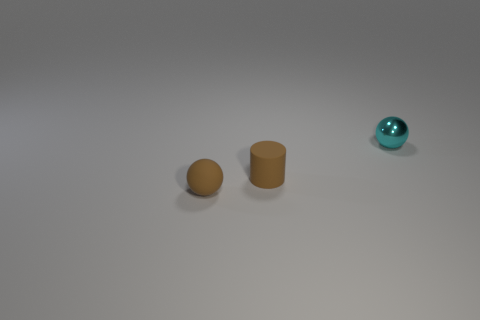Add 3 small cyan metal things. How many objects exist? 6 Subtract all spheres. How many objects are left? 1 Subtract all brown objects. Subtract all small cyan things. How many objects are left? 0 Add 2 cyan spheres. How many cyan spheres are left? 3 Add 2 green balls. How many green balls exist? 2 Subtract 1 cyan balls. How many objects are left? 2 